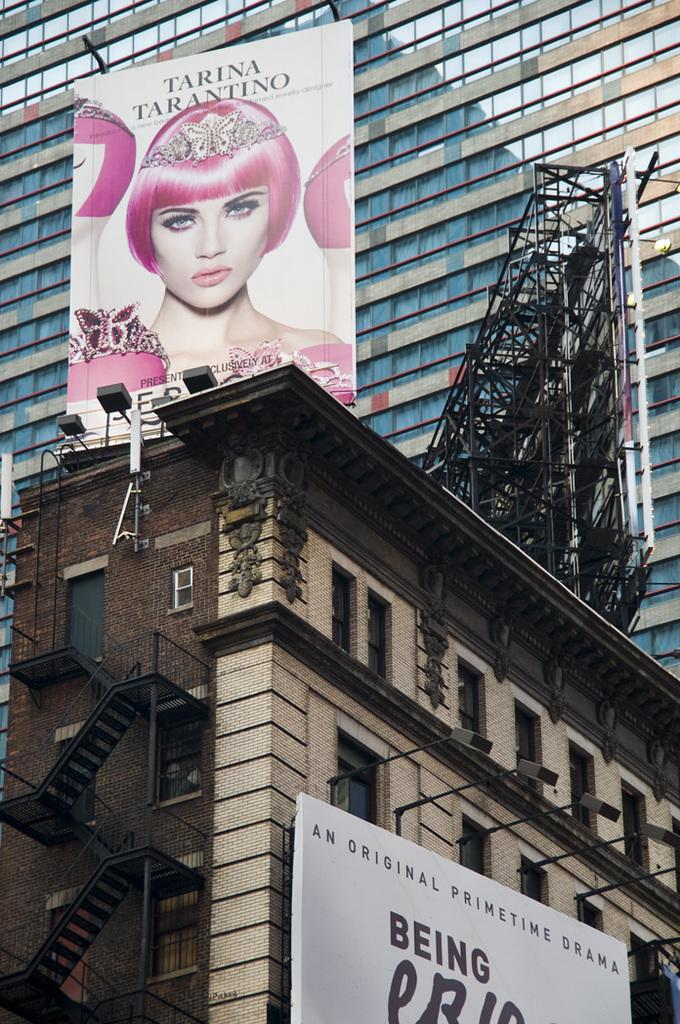What type of architectural feature is located on the left side of the image? There are stairs on the left side of the image. What type of decorative elements can be seen in the image? There are banners in the image. What type of structures are visible in the image? There are buildings in the image. Can you tell me how many ants are crawling on the banners in the image? There are no ants present on the banners in the image. What type of insurance policy is being advertised on the banners in the image? There is no information about insurance policies on the banners in the image. 